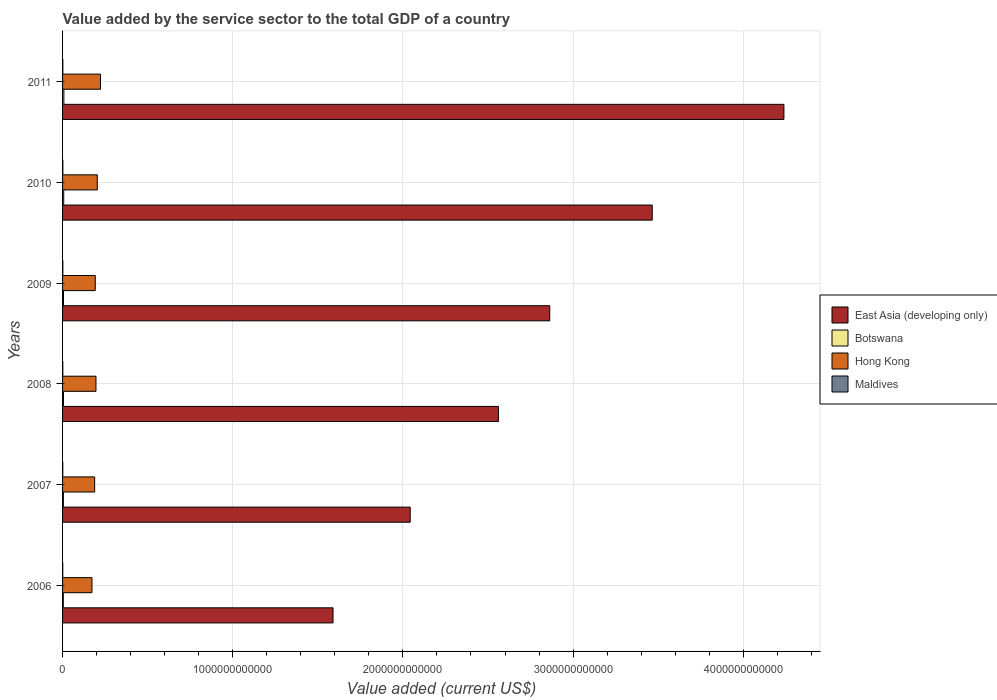How many different coloured bars are there?
Keep it short and to the point. 4. How many groups of bars are there?
Keep it short and to the point. 6. Are the number of bars per tick equal to the number of legend labels?
Provide a succinct answer. Yes. How many bars are there on the 3rd tick from the top?
Your response must be concise. 4. How many bars are there on the 4th tick from the bottom?
Your answer should be compact. 4. What is the label of the 4th group of bars from the top?
Keep it short and to the point. 2008. In how many cases, is the number of bars for a given year not equal to the number of legend labels?
Offer a terse response. 0. What is the value added by the service sector to the total GDP in Maldives in 2008?
Ensure brevity in your answer.  1.44e+09. Across all years, what is the maximum value added by the service sector to the total GDP in Hong Kong?
Ensure brevity in your answer.  2.23e+11. Across all years, what is the minimum value added by the service sector to the total GDP in East Asia (developing only)?
Give a very brief answer. 1.59e+12. In which year was the value added by the service sector to the total GDP in Botswana minimum?
Your answer should be very brief. 2006. What is the total value added by the service sector to the total GDP in East Asia (developing only) in the graph?
Provide a short and direct response. 1.68e+13. What is the difference between the value added by the service sector to the total GDP in Hong Kong in 2007 and that in 2009?
Provide a short and direct response. -3.54e+09. What is the difference between the value added by the service sector to the total GDP in Maldives in 2010 and the value added by the service sector to the total GDP in East Asia (developing only) in 2009?
Give a very brief answer. -2.86e+12. What is the average value added by the service sector to the total GDP in Maldives per year?
Your answer should be very brief. 1.45e+09. In the year 2009, what is the difference between the value added by the service sector to the total GDP in East Asia (developing only) and value added by the service sector to the total GDP in Botswana?
Your answer should be compact. 2.86e+12. What is the ratio of the value added by the service sector to the total GDP in East Asia (developing only) in 2006 to that in 2010?
Your response must be concise. 0.46. Is the difference between the value added by the service sector to the total GDP in East Asia (developing only) in 2007 and 2008 greater than the difference between the value added by the service sector to the total GDP in Botswana in 2007 and 2008?
Offer a terse response. No. What is the difference between the highest and the second highest value added by the service sector to the total GDP in Botswana?
Offer a very short reply. 9.44e+08. What is the difference between the highest and the lowest value added by the service sector to the total GDP in Botswana?
Provide a succinct answer. 3.30e+09. In how many years, is the value added by the service sector to the total GDP in Maldives greater than the average value added by the service sector to the total GDP in Maldives taken over all years?
Offer a terse response. 3. Is it the case that in every year, the sum of the value added by the service sector to the total GDP in Hong Kong and value added by the service sector to the total GDP in Maldives is greater than the sum of value added by the service sector to the total GDP in East Asia (developing only) and value added by the service sector to the total GDP in Botswana?
Give a very brief answer. Yes. What does the 4th bar from the top in 2009 represents?
Your answer should be compact. East Asia (developing only). What does the 3rd bar from the bottom in 2011 represents?
Ensure brevity in your answer.  Hong Kong. Is it the case that in every year, the sum of the value added by the service sector to the total GDP in Hong Kong and value added by the service sector to the total GDP in Maldives is greater than the value added by the service sector to the total GDP in East Asia (developing only)?
Provide a succinct answer. No. How many years are there in the graph?
Ensure brevity in your answer.  6. What is the difference between two consecutive major ticks on the X-axis?
Provide a short and direct response. 1.00e+12. Does the graph contain any zero values?
Give a very brief answer. No. Where does the legend appear in the graph?
Offer a terse response. Center right. How many legend labels are there?
Provide a short and direct response. 4. What is the title of the graph?
Give a very brief answer. Value added by the service sector to the total GDP of a country. What is the label or title of the X-axis?
Offer a terse response. Value added (current US$). What is the label or title of the Y-axis?
Provide a short and direct response. Years. What is the Value added (current US$) in East Asia (developing only) in 2006?
Your answer should be compact. 1.59e+12. What is the Value added (current US$) in Botswana in 2006?
Give a very brief answer. 4.38e+09. What is the Value added (current US$) in Hong Kong in 2006?
Your answer should be very brief. 1.73e+11. What is the Value added (current US$) of Maldives in 2006?
Ensure brevity in your answer.  1.04e+09. What is the Value added (current US$) in East Asia (developing only) in 2007?
Provide a short and direct response. 2.04e+12. What is the Value added (current US$) in Botswana in 2007?
Keep it short and to the point. 4.83e+09. What is the Value added (current US$) of Hong Kong in 2007?
Give a very brief answer. 1.89e+11. What is the Value added (current US$) of Maldives in 2007?
Offer a very short reply. 1.25e+09. What is the Value added (current US$) of East Asia (developing only) in 2008?
Keep it short and to the point. 2.56e+12. What is the Value added (current US$) in Botswana in 2008?
Provide a succinct answer. 5.30e+09. What is the Value added (current US$) of Hong Kong in 2008?
Your answer should be compact. 1.96e+11. What is the Value added (current US$) in Maldives in 2008?
Offer a terse response. 1.44e+09. What is the Value added (current US$) in East Asia (developing only) in 2009?
Your answer should be compact. 2.86e+12. What is the Value added (current US$) in Botswana in 2009?
Ensure brevity in your answer.  5.62e+09. What is the Value added (current US$) of Hong Kong in 2009?
Keep it short and to the point. 1.92e+11. What is the Value added (current US$) in Maldives in 2009?
Offer a very short reply. 1.60e+09. What is the Value added (current US$) of East Asia (developing only) in 2010?
Your answer should be very brief. 3.47e+12. What is the Value added (current US$) in Botswana in 2010?
Offer a terse response. 6.73e+09. What is the Value added (current US$) of Hong Kong in 2010?
Provide a succinct answer. 2.04e+11. What is the Value added (current US$) in Maldives in 2010?
Keep it short and to the point. 1.71e+09. What is the Value added (current US$) in East Asia (developing only) in 2011?
Offer a very short reply. 4.24e+12. What is the Value added (current US$) of Botswana in 2011?
Keep it short and to the point. 7.68e+09. What is the Value added (current US$) in Hong Kong in 2011?
Make the answer very short. 2.23e+11. What is the Value added (current US$) in Maldives in 2011?
Your answer should be compact. 1.67e+09. Across all years, what is the maximum Value added (current US$) of East Asia (developing only)?
Keep it short and to the point. 4.24e+12. Across all years, what is the maximum Value added (current US$) of Botswana?
Your response must be concise. 7.68e+09. Across all years, what is the maximum Value added (current US$) of Hong Kong?
Your response must be concise. 2.23e+11. Across all years, what is the maximum Value added (current US$) of Maldives?
Keep it short and to the point. 1.71e+09. Across all years, what is the minimum Value added (current US$) of East Asia (developing only)?
Your answer should be very brief. 1.59e+12. Across all years, what is the minimum Value added (current US$) of Botswana?
Provide a succinct answer. 4.38e+09. Across all years, what is the minimum Value added (current US$) of Hong Kong?
Your answer should be very brief. 1.73e+11. Across all years, what is the minimum Value added (current US$) of Maldives?
Offer a terse response. 1.04e+09. What is the total Value added (current US$) of East Asia (developing only) in the graph?
Give a very brief answer. 1.68e+13. What is the total Value added (current US$) of Botswana in the graph?
Your response must be concise. 3.45e+1. What is the total Value added (current US$) of Hong Kong in the graph?
Offer a very short reply. 1.18e+12. What is the total Value added (current US$) of Maldives in the graph?
Offer a very short reply. 8.72e+09. What is the difference between the Value added (current US$) in East Asia (developing only) in 2006 and that in 2007?
Your answer should be compact. -4.54e+11. What is the difference between the Value added (current US$) in Botswana in 2006 and that in 2007?
Make the answer very short. -4.51e+08. What is the difference between the Value added (current US$) of Hong Kong in 2006 and that in 2007?
Your answer should be very brief. -1.59e+1. What is the difference between the Value added (current US$) in Maldives in 2006 and that in 2007?
Your answer should be compact. -2.07e+08. What is the difference between the Value added (current US$) of East Asia (developing only) in 2006 and that in 2008?
Provide a short and direct response. -9.72e+11. What is the difference between the Value added (current US$) in Botswana in 2006 and that in 2008?
Ensure brevity in your answer.  -9.17e+08. What is the difference between the Value added (current US$) of Hong Kong in 2006 and that in 2008?
Your answer should be compact. -2.36e+1. What is the difference between the Value added (current US$) in Maldives in 2006 and that in 2008?
Your answer should be very brief. -4.00e+08. What is the difference between the Value added (current US$) of East Asia (developing only) in 2006 and that in 2009?
Offer a very short reply. -1.27e+12. What is the difference between the Value added (current US$) in Botswana in 2006 and that in 2009?
Provide a short and direct response. -1.24e+09. What is the difference between the Value added (current US$) of Hong Kong in 2006 and that in 2009?
Provide a short and direct response. -1.94e+1. What is the difference between the Value added (current US$) of Maldives in 2006 and that in 2009?
Give a very brief answer. -5.57e+08. What is the difference between the Value added (current US$) of East Asia (developing only) in 2006 and that in 2010?
Your answer should be compact. -1.88e+12. What is the difference between the Value added (current US$) in Botswana in 2006 and that in 2010?
Offer a very short reply. -2.35e+09. What is the difference between the Value added (current US$) of Hong Kong in 2006 and that in 2010?
Your answer should be compact. -3.13e+1. What is the difference between the Value added (current US$) in Maldives in 2006 and that in 2010?
Ensure brevity in your answer.  -6.67e+08. What is the difference between the Value added (current US$) in East Asia (developing only) in 2006 and that in 2011?
Offer a very short reply. -2.65e+12. What is the difference between the Value added (current US$) of Botswana in 2006 and that in 2011?
Give a very brief answer. -3.30e+09. What is the difference between the Value added (current US$) in Hong Kong in 2006 and that in 2011?
Make the answer very short. -5.00e+1. What is the difference between the Value added (current US$) in Maldives in 2006 and that in 2011?
Ensure brevity in your answer.  -6.25e+08. What is the difference between the Value added (current US$) in East Asia (developing only) in 2007 and that in 2008?
Your response must be concise. -5.18e+11. What is the difference between the Value added (current US$) of Botswana in 2007 and that in 2008?
Your answer should be compact. -4.65e+08. What is the difference between the Value added (current US$) in Hong Kong in 2007 and that in 2008?
Your answer should be compact. -7.73e+09. What is the difference between the Value added (current US$) of Maldives in 2007 and that in 2008?
Provide a short and direct response. -1.93e+08. What is the difference between the Value added (current US$) in East Asia (developing only) in 2007 and that in 2009?
Provide a short and direct response. -8.20e+11. What is the difference between the Value added (current US$) in Botswana in 2007 and that in 2009?
Your answer should be compact. -7.86e+08. What is the difference between the Value added (current US$) in Hong Kong in 2007 and that in 2009?
Offer a very short reply. -3.54e+09. What is the difference between the Value added (current US$) of Maldives in 2007 and that in 2009?
Provide a short and direct response. -3.49e+08. What is the difference between the Value added (current US$) of East Asia (developing only) in 2007 and that in 2010?
Give a very brief answer. -1.42e+12. What is the difference between the Value added (current US$) in Botswana in 2007 and that in 2010?
Provide a succinct answer. -1.90e+09. What is the difference between the Value added (current US$) of Hong Kong in 2007 and that in 2010?
Your response must be concise. -1.54e+1. What is the difference between the Value added (current US$) of Maldives in 2007 and that in 2010?
Provide a short and direct response. -4.60e+08. What is the difference between the Value added (current US$) in East Asia (developing only) in 2007 and that in 2011?
Make the answer very short. -2.20e+12. What is the difference between the Value added (current US$) in Botswana in 2007 and that in 2011?
Keep it short and to the point. -2.85e+09. What is the difference between the Value added (current US$) of Hong Kong in 2007 and that in 2011?
Keep it short and to the point. -3.42e+1. What is the difference between the Value added (current US$) in Maldives in 2007 and that in 2011?
Offer a very short reply. -4.17e+08. What is the difference between the Value added (current US$) of East Asia (developing only) in 2008 and that in 2009?
Your answer should be very brief. -3.02e+11. What is the difference between the Value added (current US$) of Botswana in 2008 and that in 2009?
Your response must be concise. -3.20e+08. What is the difference between the Value added (current US$) in Hong Kong in 2008 and that in 2009?
Ensure brevity in your answer.  4.19e+09. What is the difference between the Value added (current US$) of Maldives in 2008 and that in 2009?
Ensure brevity in your answer.  -1.57e+08. What is the difference between the Value added (current US$) of East Asia (developing only) in 2008 and that in 2010?
Ensure brevity in your answer.  -9.04e+11. What is the difference between the Value added (current US$) in Botswana in 2008 and that in 2010?
Provide a short and direct response. -1.44e+09. What is the difference between the Value added (current US$) in Hong Kong in 2008 and that in 2010?
Offer a terse response. -7.71e+09. What is the difference between the Value added (current US$) of Maldives in 2008 and that in 2010?
Keep it short and to the point. -2.67e+08. What is the difference between the Value added (current US$) in East Asia (developing only) in 2008 and that in 2011?
Your response must be concise. -1.68e+12. What is the difference between the Value added (current US$) of Botswana in 2008 and that in 2011?
Give a very brief answer. -2.38e+09. What is the difference between the Value added (current US$) of Hong Kong in 2008 and that in 2011?
Provide a short and direct response. -2.65e+1. What is the difference between the Value added (current US$) in Maldives in 2008 and that in 2011?
Ensure brevity in your answer.  -2.25e+08. What is the difference between the Value added (current US$) in East Asia (developing only) in 2009 and that in 2010?
Offer a very short reply. -6.02e+11. What is the difference between the Value added (current US$) in Botswana in 2009 and that in 2010?
Make the answer very short. -1.12e+09. What is the difference between the Value added (current US$) of Hong Kong in 2009 and that in 2010?
Your answer should be very brief. -1.19e+1. What is the difference between the Value added (current US$) of Maldives in 2009 and that in 2010?
Offer a terse response. -1.10e+08. What is the difference between the Value added (current US$) of East Asia (developing only) in 2009 and that in 2011?
Provide a short and direct response. -1.38e+12. What is the difference between the Value added (current US$) in Botswana in 2009 and that in 2011?
Your answer should be compact. -2.06e+09. What is the difference between the Value added (current US$) of Hong Kong in 2009 and that in 2011?
Offer a very short reply. -3.06e+1. What is the difference between the Value added (current US$) in Maldives in 2009 and that in 2011?
Your answer should be very brief. -6.81e+07. What is the difference between the Value added (current US$) of East Asia (developing only) in 2010 and that in 2011?
Your answer should be very brief. -7.74e+11. What is the difference between the Value added (current US$) in Botswana in 2010 and that in 2011?
Provide a succinct answer. -9.44e+08. What is the difference between the Value added (current US$) of Hong Kong in 2010 and that in 2011?
Offer a terse response. -1.87e+1. What is the difference between the Value added (current US$) of Maldives in 2010 and that in 2011?
Offer a very short reply. 4.22e+07. What is the difference between the Value added (current US$) of East Asia (developing only) in 2006 and the Value added (current US$) of Botswana in 2007?
Offer a very short reply. 1.58e+12. What is the difference between the Value added (current US$) of East Asia (developing only) in 2006 and the Value added (current US$) of Hong Kong in 2007?
Keep it short and to the point. 1.40e+12. What is the difference between the Value added (current US$) in East Asia (developing only) in 2006 and the Value added (current US$) in Maldives in 2007?
Your response must be concise. 1.59e+12. What is the difference between the Value added (current US$) of Botswana in 2006 and the Value added (current US$) of Hong Kong in 2007?
Provide a succinct answer. -1.84e+11. What is the difference between the Value added (current US$) in Botswana in 2006 and the Value added (current US$) in Maldives in 2007?
Your answer should be very brief. 3.13e+09. What is the difference between the Value added (current US$) of Hong Kong in 2006 and the Value added (current US$) of Maldives in 2007?
Provide a short and direct response. 1.71e+11. What is the difference between the Value added (current US$) in East Asia (developing only) in 2006 and the Value added (current US$) in Botswana in 2008?
Provide a succinct answer. 1.58e+12. What is the difference between the Value added (current US$) in East Asia (developing only) in 2006 and the Value added (current US$) in Hong Kong in 2008?
Your response must be concise. 1.39e+12. What is the difference between the Value added (current US$) of East Asia (developing only) in 2006 and the Value added (current US$) of Maldives in 2008?
Provide a short and direct response. 1.59e+12. What is the difference between the Value added (current US$) in Botswana in 2006 and the Value added (current US$) in Hong Kong in 2008?
Provide a succinct answer. -1.92e+11. What is the difference between the Value added (current US$) of Botswana in 2006 and the Value added (current US$) of Maldives in 2008?
Give a very brief answer. 2.94e+09. What is the difference between the Value added (current US$) of Hong Kong in 2006 and the Value added (current US$) of Maldives in 2008?
Ensure brevity in your answer.  1.71e+11. What is the difference between the Value added (current US$) in East Asia (developing only) in 2006 and the Value added (current US$) in Botswana in 2009?
Provide a succinct answer. 1.58e+12. What is the difference between the Value added (current US$) of East Asia (developing only) in 2006 and the Value added (current US$) of Hong Kong in 2009?
Make the answer very short. 1.40e+12. What is the difference between the Value added (current US$) in East Asia (developing only) in 2006 and the Value added (current US$) in Maldives in 2009?
Make the answer very short. 1.59e+12. What is the difference between the Value added (current US$) in Botswana in 2006 and the Value added (current US$) in Hong Kong in 2009?
Provide a short and direct response. -1.88e+11. What is the difference between the Value added (current US$) of Botswana in 2006 and the Value added (current US$) of Maldives in 2009?
Offer a very short reply. 2.78e+09. What is the difference between the Value added (current US$) of Hong Kong in 2006 and the Value added (current US$) of Maldives in 2009?
Your answer should be very brief. 1.71e+11. What is the difference between the Value added (current US$) in East Asia (developing only) in 2006 and the Value added (current US$) in Botswana in 2010?
Ensure brevity in your answer.  1.58e+12. What is the difference between the Value added (current US$) of East Asia (developing only) in 2006 and the Value added (current US$) of Hong Kong in 2010?
Your answer should be compact. 1.39e+12. What is the difference between the Value added (current US$) of East Asia (developing only) in 2006 and the Value added (current US$) of Maldives in 2010?
Give a very brief answer. 1.59e+12. What is the difference between the Value added (current US$) in Botswana in 2006 and the Value added (current US$) in Hong Kong in 2010?
Your answer should be compact. -2.00e+11. What is the difference between the Value added (current US$) in Botswana in 2006 and the Value added (current US$) in Maldives in 2010?
Make the answer very short. 2.67e+09. What is the difference between the Value added (current US$) in Hong Kong in 2006 and the Value added (current US$) in Maldives in 2010?
Keep it short and to the point. 1.71e+11. What is the difference between the Value added (current US$) of East Asia (developing only) in 2006 and the Value added (current US$) of Botswana in 2011?
Make the answer very short. 1.58e+12. What is the difference between the Value added (current US$) of East Asia (developing only) in 2006 and the Value added (current US$) of Hong Kong in 2011?
Give a very brief answer. 1.37e+12. What is the difference between the Value added (current US$) in East Asia (developing only) in 2006 and the Value added (current US$) in Maldives in 2011?
Your answer should be compact. 1.59e+12. What is the difference between the Value added (current US$) in Botswana in 2006 and the Value added (current US$) in Hong Kong in 2011?
Your answer should be very brief. -2.18e+11. What is the difference between the Value added (current US$) of Botswana in 2006 and the Value added (current US$) of Maldives in 2011?
Keep it short and to the point. 2.71e+09. What is the difference between the Value added (current US$) in Hong Kong in 2006 and the Value added (current US$) in Maldives in 2011?
Your answer should be compact. 1.71e+11. What is the difference between the Value added (current US$) in East Asia (developing only) in 2007 and the Value added (current US$) in Botswana in 2008?
Your response must be concise. 2.04e+12. What is the difference between the Value added (current US$) in East Asia (developing only) in 2007 and the Value added (current US$) in Hong Kong in 2008?
Make the answer very short. 1.85e+12. What is the difference between the Value added (current US$) in East Asia (developing only) in 2007 and the Value added (current US$) in Maldives in 2008?
Offer a terse response. 2.04e+12. What is the difference between the Value added (current US$) in Botswana in 2007 and the Value added (current US$) in Hong Kong in 2008?
Your answer should be compact. -1.91e+11. What is the difference between the Value added (current US$) in Botswana in 2007 and the Value added (current US$) in Maldives in 2008?
Give a very brief answer. 3.39e+09. What is the difference between the Value added (current US$) in Hong Kong in 2007 and the Value added (current US$) in Maldives in 2008?
Your answer should be very brief. 1.87e+11. What is the difference between the Value added (current US$) in East Asia (developing only) in 2007 and the Value added (current US$) in Botswana in 2009?
Keep it short and to the point. 2.04e+12. What is the difference between the Value added (current US$) in East Asia (developing only) in 2007 and the Value added (current US$) in Hong Kong in 2009?
Offer a terse response. 1.85e+12. What is the difference between the Value added (current US$) in East Asia (developing only) in 2007 and the Value added (current US$) in Maldives in 2009?
Make the answer very short. 2.04e+12. What is the difference between the Value added (current US$) in Botswana in 2007 and the Value added (current US$) in Hong Kong in 2009?
Give a very brief answer. -1.87e+11. What is the difference between the Value added (current US$) in Botswana in 2007 and the Value added (current US$) in Maldives in 2009?
Offer a very short reply. 3.23e+09. What is the difference between the Value added (current US$) in Hong Kong in 2007 and the Value added (current US$) in Maldives in 2009?
Offer a very short reply. 1.87e+11. What is the difference between the Value added (current US$) in East Asia (developing only) in 2007 and the Value added (current US$) in Botswana in 2010?
Ensure brevity in your answer.  2.04e+12. What is the difference between the Value added (current US$) in East Asia (developing only) in 2007 and the Value added (current US$) in Hong Kong in 2010?
Your response must be concise. 1.84e+12. What is the difference between the Value added (current US$) in East Asia (developing only) in 2007 and the Value added (current US$) in Maldives in 2010?
Your answer should be very brief. 2.04e+12. What is the difference between the Value added (current US$) in Botswana in 2007 and the Value added (current US$) in Hong Kong in 2010?
Your response must be concise. -1.99e+11. What is the difference between the Value added (current US$) of Botswana in 2007 and the Value added (current US$) of Maldives in 2010?
Your answer should be very brief. 3.12e+09. What is the difference between the Value added (current US$) in Hong Kong in 2007 and the Value added (current US$) in Maldives in 2010?
Your answer should be very brief. 1.87e+11. What is the difference between the Value added (current US$) of East Asia (developing only) in 2007 and the Value added (current US$) of Botswana in 2011?
Offer a terse response. 2.04e+12. What is the difference between the Value added (current US$) in East Asia (developing only) in 2007 and the Value added (current US$) in Hong Kong in 2011?
Offer a very short reply. 1.82e+12. What is the difference between the Value added (current US$) in East Asia (developing only) in 2007 and the Value added (current US$) in Maldives in 2011?
Make the answer very short. 2.04e+12. What is the difference between the Value added (current US$) of Botswana in 2007 and the Value added (current US$) of Hong Kong in 2011?
Provide a short and direct response. -2.18e+11. What is the difference between the Value added (current US$) of Botswana in 2007 and the Value added (current US$) of Maldives in 2011?
Provide a short and direct response. 3.16e+09. What is the difference between the Value added (current US$) in Hong Kong in 2007 and the Value added (current US$) in Maldives in 2011?
Offer a very short reply. 1.87e+11. What is the difference between the Value added (current US$) in East Asia (developing only) in 2008 and the Value added (current US$) in Botswana in 2009?
Make the answer very short. 2.56e+12. What is the difference between the Value added (current US$) of East Asia (developing only) in 2008 and the Value added (current US$) of Hong Kong in 2009?
Your answer should be very brief. 2.37e+12. What is the difference between the Value added (current US$) in East Asia (developing only) in 2008 and the Value added (current US$) in Maldives in 2009?
Offer a terse response. 2.56e+12. What is the difference between the Value added (current US$) in Botswana in 2008 and the Value added (current US$) in Hong Kong in 2009?
Keep it short and to the point. -1.87e+11. What is the difference between the Value added (current US$) of Botswana in 2008 and the Value added (current US$) of Maldives in 2009?
Keep it short and to the point. 3.70e+09. What is the difference between the Value added (current US$) in Hong Kong in 2008 and the Value added (current US$) in Maldives in 2009?
Offer a terse response. 1.95e+11. What is the difference between the Value added (current US$) in East Asia (developing only) in 2008 and the Value added (current US$) in Botswana in 2010?
Give a very brief answer. 2.55e+12. What is the difference between the Value added (current US$) in East Asia (developing only) in 2008 and the Value added (current US$) in Hong Kong in 2010?
Your answer should be compact. 2.36e+12. What is the difference between the Value added (current US$) of East Asia (developing only) in 2008 and the Value added (current US$) of Maldives in 2010?
Provide a succinct answer. 2.56e+12. What is the difference between the Value added (current US$) of Botswana in 2008 and the Value added (current US$) of Hong Kong in 2010?
Make the answer very short. -1.99e+11. What is the difference between the Value added (current US$) of Botswana in 2008 and the Value added (current US$) of Maldives in 2010?
Offer a terse response. 3.59e+09. What is the difference between the Value added (current US$) of Hong Kong in 2008 and the Value added (current US$) of Maldives in 2010?
Give a very brief answer. 1.95e+11. What is the difference between the Value added (current US$) in East Asia (developing only) in 2008 and the Value added (current US$) in Botswana in 2011?
Keep it short and to the point. 2.55e+12. What is the difference between the Value added (current US$) of East Asia (developing only) in 2008 and the Value added (current US$) of Hong Kong in 2011?
Offer a terse response. 2.34e+12. What is the difference between the Value added (current US$) of East Asia (developing only) in 2008 and the Value added (current US$) of Maldives in 2011?
Offer a terse response. 2.56e+12. What is the difference between the Value added (current US$) in Botswana in 2008 and the Value added (current US$) in Hong Kong in 2011?
Offer a very short reply. -2.17e+11. What is the difference between the Value added (current US$) of Botswana in 2008 and the Value added (current US$) of Maldives in 2011?
Provide a succinct answer. 3.63e+09. What is the difference between the Value added (current US$) of Hong Kong in 2008 and the Value added (current US$) of Maldives in 2011?
Your response must be concise. 1.95e+11. What is the difference between the Value added (current US$) of East Asia (developing only) in 2009 and the Value added (current US$) of Botswana in 2010?
Make the answer very short. 2.86e+12. What is the difference between the Value added (current US$) of East Asia (developing only) in 2009 and the Value added (current US$) of Hong Kong in 2010?
Provide a short and direct response. 2.66e+12. What is the difference between the Value added (current US$) in East Asia (developing only) in 2009 and the Value added (current US$) in Maldives in 2010?
Ensure brevity in your answer.  2.86e+12. What is the difference between the Value added (current US$) of Botswana in 2009 and the Value added (current US$) of Hong Kong in 2010?
Keep it short and to the point. -1.98e+11. What is the difference between the Value added (current US$) of Botswana in 2009 and the Value added (current US$) of Maldives in 2010?
Your response must be concise. 3.91e+09. What is the difference between the Value added (current US$) of Hong Kong in 2009 and the Value added (current US$) of Maldives in 2010?
Your answer should be compact. 1.90e+11. What is the difference between the Value added (current US$) of East Asia (developing only) in 2009 and the Value added (current US$) of Botswana in 2011?
Give a very brief answer. 2.86e+12. What is the difference between the Value added (current US$) in East Asia (developing only) in 2009 and the Value added (current US$) in Hong Kong in 2011?
Make the answer very short. 2.64e+12. What is the difference between the Value added (current US$) of East Asia (developing only) in 2009 and the Value added (current US$) of Maldives in 2011?
Ensure brevity in your answer.  2.86e+12. What is the difference between the Value added (current US$) in Botswana in 2009 and the Value added (current US$) in Hong Kong in 2011?
Your response must be concise. -2.17e+11. What is the difference between the Value added (current US$) in Botswana in 2009 and the Value added (current US$) in Maldives in 2011?
Ensure brevity in your answer.  3.95e+09. What is the difference between the Value added (current US$) in Hong Kong in 2009 and the Value added (current US$) in Maldives in 2011?
Provide a short and direct response. 1.90e+11. What is the difference between the Value added (current US$) of East Asia (developing only) in 2010 and the Value added (current US$) of Botswana in 2011?
Keep it short and to the point. 3.46e+12. What is the difference between the Value added (current US$) in East Asia (developing only) in 2010 and the Value added (current US$) in Hong Kong in 2011?
Your response must be concise. 3.24e+12. What is the difference between the Value added (current US$) of East Asia (developing only) in 2010 and the Value added (current US$) of Maldives in 2011?
Ensure brevity in your answer.  3.46e+12. What is the difference between the Value added (current US$) of Botswana in 2010 and the Value added (current US$) of Hong Kong in 2011?
Make the answer very short. -2.16e+11. What is the difference between the Value added (current US$) of Botswana in 2010 and the Value added (current US$) of Maldives in 2011?
Offer a very short reply. 5.07e+09. What is the difference between the Value added (current US$) in Hong Kong in 2010 and the Value added (current US$) in Maldives in 2011?
Your answer should be compact. 2.02e+11. What is the average Value added (current US$) of East Asia (developing only) per year?
Give a very brief answer. 2.79e+12. What is the average Value added (current US$) in Botswana per year?
Keep it short and to the point. 5.76e+09. What is the average Value added (current US$) of Hong Kong per year?
Provide a succinct answer. 1.96e+11. What is the average Value added (current US$) of Maldives per year?
Provide a succinct answer. 1.45e+09. In the year 2006, what is the difference between the Value added (current US$) in East Asia (developing only) and Value added (current US$) in Botswana?
Give a very brief answer. 1.59e+12. In the year 2006, what is the difference between the Value added (current US$) of East Asia (developing only) and Value added (current US$) of Hong Kong?
Your answer should be very brief. 1.42e+12. In the year 2006, what is the difference between the Value added (current US$) of East Asia (developing only) and Value added (current US$) of Maldives?
Provide a short and direct response. 1.59e+12. In the year 2006, what is the difference between the Value added (current US$) in Botswana and Value added (current US$) in Hong Kong?
Offer a terse response. -1.68e+11. In the year 2006, what is the difference between the Value added (current US$) in Botswana and Value added (current US$) in Maldives?
Provide a short and direct response. 3.34e+09. In the year 2006, what is the difference between the Value added (current US$) in Hong Kong and Value added (current US$) in Maldives?
Your answer should be compact. 1.72e+11. In the year 2007, what is the difference between the Value added (current US$) in East Asia (developing only) and Value added (current US$) in Botswana?
Your answer should be very brief. 2.04e+12. In the year 2007, what is the difference between the Value added (current US$) in East Asia (developing only) and Value added (current US$) in Hong Kong?
Your answer should be compact. 1.85e+12. In the year 2007, what is the difference between the Value added (current US$) in East Asia (developing only) and Value added (current US$) in Maldives?
Offer a very short reply. 2.04e+12. In the year 2007, what is the difference between the Value added (current US$) of Botswana and Value added (current US$) of Hong Kong?
Make the answer very short. -1.84e+11. In the year 2007, what is the difference between the Value added (current US$) of Botswana and Value added (current US$) of Maldives?
Give a very brief answer. 3.58e+09. In the year 2007, what is the difference between the Value added (current US$) of Hong Kong and Value added (current US$) of Maldives?
Offer a terse response. 1.87e+11. In the year 2008, what is the difference between the Value added (current US$) in East Asia (developing only) and Value added (current US$) in Botswana?
Offer a very short reply. 2.56e+12. In the year 2008, what is the difference between the Value added (current US$) in East Asia (developing only) and Value added (current US$) in Hong Kong?
Provide a succinct answer. 2.36e+12. In the year 2008, what is the difference between the Value added (current US$) in East Asia (developing only) and Value added (current US$) in Maldives?
Your answer should be compact. 2.56e+12. In the year 2008, what is the difference between the Value added (current US$) of Botswana and Value added (current US$) of Hong Kong?
Make the answer very short. -1.91e+11. In the year 2008, what is the difference between the Value added (current US$) in Botswana and Value added (current US$) in Maldives?
Ensure brevity in your answer.  3.85e+09. In the year 2008, what is the difference between the Value added (current US$) of Hong Kong and Value added (current US$) of Maldives?
Provide a succinct answer. 1.95e+11. In the year 2009, what is the difference between the Value added (current US$) in East Asia (developing only) and Value added (current US$) in Botswana?
Offer a terse response. 2.86e+12. In the year 2009, what is the difference between the Value added (current US$) of East Asia (developing only) and Value added (current US$) of Hong Kong?
Ensure brevity in your answer.  2.67e+12. In the year 2009, what is the difference between the Value added (current US$) in East Asia (developing only) and Value added (current US$) in Maldives?
Offer a terse response. 2.86e+12. In the year 2009, what is the difference between the Value added (current US$) of Botswana and Value added (current US$) of Hong Kong?
Provide a succinct answer. -1.87e+11. In the year 2009, what is the difference between the Value added (current US$) in Botswana and Value added (current US$) in Maldives?
Make the answer very short. 4.02e+09. In the year 2009, what is the difference between the Value added (current US$) in Hong Kong and Value added (current US$) in Maldives?
Provide a succinct answer. 1.91e+11. In the year 2010, what is the difference between the Value added (current US$) of East Asia (developing only) and Value added (current US$) of Botswana?
Offer a terse response. 3.46e+12. In the year 2010, what is the difference between the Value added (current US$) of East Asia (developing only) and Value added (current US$) of Hong Kong?
Your answer should be compact. 3.26e+12. In the year 2010, what is the difference between the Value added (current US$) of East Asia (developing only) and Value added (current US$) of Maldives?
Provide a succinct answer. 3.46e+12. In the year 2010, what is the difference between the Value added (current US$) of Botswana and Value added (current US$) of Hong Kong?
Give a very brief answer. -1.97e+11. In the year 2010, what is the difference between the Value added (current US$) in Botswana and Value added (current US$) in Maldives?
Offer a terse response. 5.02e+09. In the year 2010, what is the difference between the Value added (current US$) in Hong Kong and Value added (current US$) in Maldives?
Give a very brief answer. 2.02e+11. In the year 2011, what is the difference between the Value added (current US$) of East Asia (developing only) and Value added (current US$) of Botswana?
Your answer should be compact. 4.23e+12. In the year 2011, what is the difference between the Value added (current US$) in East Asia (developing only) and Value added (current US$) in Hong Kong?
Make the answer very short. 4.02e+12. In the year 2011, what is the difference between the Value added (current US$) of East Asia (developing only) and Value added (current US$) of Maldives?
Give a very brief answer. 4.24e+12. In the year 2011, what is the difference between the Value added (current US$) in Botswana and Value added (current US$) in Hong Kong?
Provide a succinct answer. -2.15e+11. In the year 2011, what is the difference between the Value added (current US$) in Botswana and Value added (current US$) in Maldives?
Your response must be concise. 6.01e+09. In the year 2011, what is the difference between the Value added (current US$) of Hong Kong and Value added (current US$) of Maldives?
Offer a terse response. 2.21e+11. What is the ratio of the Value added (current US$) of East Asia (developing only) in 2006 to that in 2007?
Your response must be concise. 0.78. What is the ratio of the Value added (current US$) of Botswana in 2006 to that in 2007?
Provide a short and direct response. 0.91. What is the ratio of the Value added (current US$) of Hong Kong in 2006 to that in 2007?
Ensure brevity in your answer.  0.92. What is the ratio of the Value added (current US$) of Maldives in 2006 to that in 2007?
Give a very brief answer. 0.83. What is the ratio of the Value added (current US$) of East Asia (developing only) in 2006 to that in 2008?
Offer a terse response. 0.62. What is the ratio of the Value added (current US$) in Botswana in 2006 to that in 2008?
Your answer should be compact. 0.83. What is the ratio of the Value added (current US$) of Hong Kong in 2006 to that in 2008?
Ensure brevity in your answer.  0.88. What is the ratio of the Value added (current US$) of Maldives in 2006 to that in 2008?
Provide a succinct answer. 0.72. What is the ratio of the Value added (current US$) of East Asia (developing only) in 2006 to that in 2009?
Make the answer very short. 0.56. What is the ratio of the Value added (current US$) in Botswana in 2006 to that in 2009?
Your answer should be very brief. 0.78. What is the ratio of the Value added (current US$) of Hong Kong in 2006 to that in 2009?
Keep it short and to the point. 0.9. What is the ratio of the Value added (current US$) in Maldives in 2006 to that in 2009?
Your response must be concise. 0.65. What is the ratio of the Value added (current US$) in East Asia (developing only) in 2006 to that in 2010?
Provide a succinct answer. 0.46. What is the ratio of the Value added (current US$) in Botswana in 2006 to that in 2010?
Ensure brevity in your answer.  0.65. What is the ratio of the Value added (current US$) of Hong Kong in 2006 to that in 2010?
Make the answer very short. 0.85. What is the ratio of the Value added (current US$) in Maldives in 2006 to that in 2010?
Keep it short and to the point. 0.61. What is the ratio of the Value added (current US$) in East Asia (developing only) in 2006 to that in 2011?
Ensure brevity in your answer.  0.37. What is the ratio of the Value added (current US$) in Botswana in 2006 to that in 2011?
Your answer should be compact. 0.57. What is the ratio of the Value added (current US$) in Hong Kong in 2006 to that in 2011?
Ensure brevity in your answer.  0.78. What is the ratio of the Value added (current US$) in Maldives in 2006 to that in 2011?
Ensure brevity in your answer.  0.63. What is the ratio of the Value added (current US$) of East Asia (developing only) in 2007 to that in 2008?
Ensure brevity in your answer.  0.8. What is the ratio of the Value added (current US$) of Botswana in 2007 to that in 2008?
Provide a short and direct response. 0.91. What is the ratio of the Value added (current US$) of Hong Kong in 2007 to that in 2008?
Give a very brief answer. 0.96. What is the ratio of the Value added (current US$) of Maldives in 2007 to that in 2008?
Ensure brevity in your answer.  0.87. What is the ratio of the Value added (current US$) of East Asia (developing only) in 2007 to that in 2009?
Offer a very short reply. 0.71. What is the ratio of the Value added (current US$) in Botswana in 2007 to that in 2009?
Offer a terse response. 0.86. What is the ratio of the Value added (current US$) in Hong Kong in 2007 to that in 2009?
Keep it short and to the point. 0.98. What is the ratio of the Value added (current US$) of Maldives in 2007 to that in 2009?
Offer a very short reply. 0.78. What is the ratio of the Value added (current US$) of East Asia (developing only) in 2007 to that in 2010?
Provide a succinct answer. 0.59. What is the ratio of the Value added (current US$) in Botswana in 2007 to that in 2010?
Provide a short and direct response. 0.72. What is the ratio of the Value added (current US$) in Hong Kong in 2007 to that in 2010?
Provide a short and direct response. 0.92. What is the ratio of the Value added (current US$) of Maldives in 2007 to that in 2010?
Offer a terse response. 0.73. What is the ratio of the Value added (current US$) of East Asia (developing only) in 2007 to that in 2011?
Keep it short and to the point. 0.48. What is the ratio of the Value added (current US$) of Botswana in 2007 to that in 2011?
Ensure brevity in your answer.  0.63. What is the ratio of the Value added (current US$) in Hong Kong in 2007 to that in 2011?
Provide a succinct answer. 0.85. What is the ratio of the Value added (current US$) of Maldives in 2007 to that in 2011?
Give a very brief answer. 0.75. What is the ratio of the Value added (current US$) of East Asia (developing only) in 2008 to that in 2009?
Your response must be concise. 0.89. What is the ratio of the Value added (current US$) of Botswana in 2008 to that in 2009?
Make the answer very short. 0.94. What is the ratio of the Value added (current US$) of Hong Kong in 2008 to that in 2009?
Ensure brevity in your answer.  1.02. What is the ratio of the Value added (current US$) of Maldives in 2008 to that in 2009?
Offer a very short reply. 0.9. What is the ratio of the Value added (current US$) in East Asia (developing only) in 2008 to that in 2010?
Make the answer very short. 0.74. What is the ratio of the Value added (current US$) of Botswana in 2008 to that in 2010?
Your answer should be very brief. 0.79. What is the ratio of the Value added (current US$) in Hong Kong in 2008 to that in 2010?
Provide a short and direct response. 0.96. What is the ratio of the Value added (current US$) of Maldives in 2008 to that in 2010?
Keep it short and to the point. 0.84. What is the ratio of the Value added (current US$) in East Asia (developing only) in 2008 to that in 2011?
Provide a short and direct response. 0.6. What is the ratio of the Value added (current US$) of Botswana in 2008 to that in 2011?
Keep it short and to the point. 0.69. What is the ratio of the Value added (current US$) of Hong Kong in 2008 to that in 2011?
Make the answer very short. 0.88. What is the ratio of the Value added (current US$) in Maldives in 2008 to that in 2011?
Give a very brief answer. 0.87. What is the ratio of the Value added (current US$) of East Asia (developing only) in 2009 to that in 2010?
Ensure brevity in your answer.  0.83. What is the ratio of the Value added (current US$) in Botswana in 2009 to that in 2010?
Your response must be concise. 0.83. What is the ratio of the Value added (current US$) in Hong Kong in 2009 to that in 2010?
Provide a short and direct response. 0.94. What is the ratio of the Value added (current US$) of Maldives in 2009 to that in 2010?
Provide a short and direct response. 0.94. What is the ratio of the Value added (current US$) in East Asia (developing only) in 2009 to that in 2011?
Offer a terse response. 0.68. What is the ratio of the Value added (current US$) of Botswana in 2009 to that in 2011?
Your answer should be very brief. 0.73. What is the ratio of the Value added (current US$) of Hong Kong in 2009 to that in 2011?
Keep it short and to the point. 0.86. What is the ratio of the Value added (current US$) of Maldives in 2009 to that in 2011?
Your answer should be compact. 0.96. What is the ratio of the Value added (current US$) in East Asia (developing only) in 2010 to that in 2011?
Provide a succinct answer. 0.82. What is the ratio of the Value added (current US$) of Botswana in 2010 to that in 2011?
Offer a very short reply. 0.88. What is the ratio of the Value added (current US$) of Hong Kong in 2010 to that in 2011?
Give a very brief answer. 0.92. What is the ratio of the Value added (current US$) of Maldives in 2010 to that in 2011?
Your response must be concise. 1.03. What is the difference between the highest and the second highest Value added (current US$) in East Asia (developing only)?
Your response must be concise. 7.74e+11. What is the difference between the highest and the second highest Value added (current US$) of Botswana?
Provide a succinct answer. 9.44e+08. What is the difference between the highest and the second highest Value added (current US$) in Hong Kong?
Give a very brief answer. 1.87e+1. What is the difference between the highest and the second highest Value added (current US$) of Maldives?
Your answer should be very brief. 4.22e+07. What is the difference between the highest and the lowest Value added (current US$) of East Asia (developing only)?
Your answer should be very brief. 2.65e+12. What is the difference between the highest and the lowest Value added (current US$) of Botswana?
Offer a very short reply. 3.30e+09. What is the difference between the highest and the lowest Value added (current US$) in Hong Kong?
Offer a very short reply. 5.00e+1. What is the difference between the highest and the lowest Value added (current US$) of Maldives?
Provide a succinct answer. 6.67e+08. 